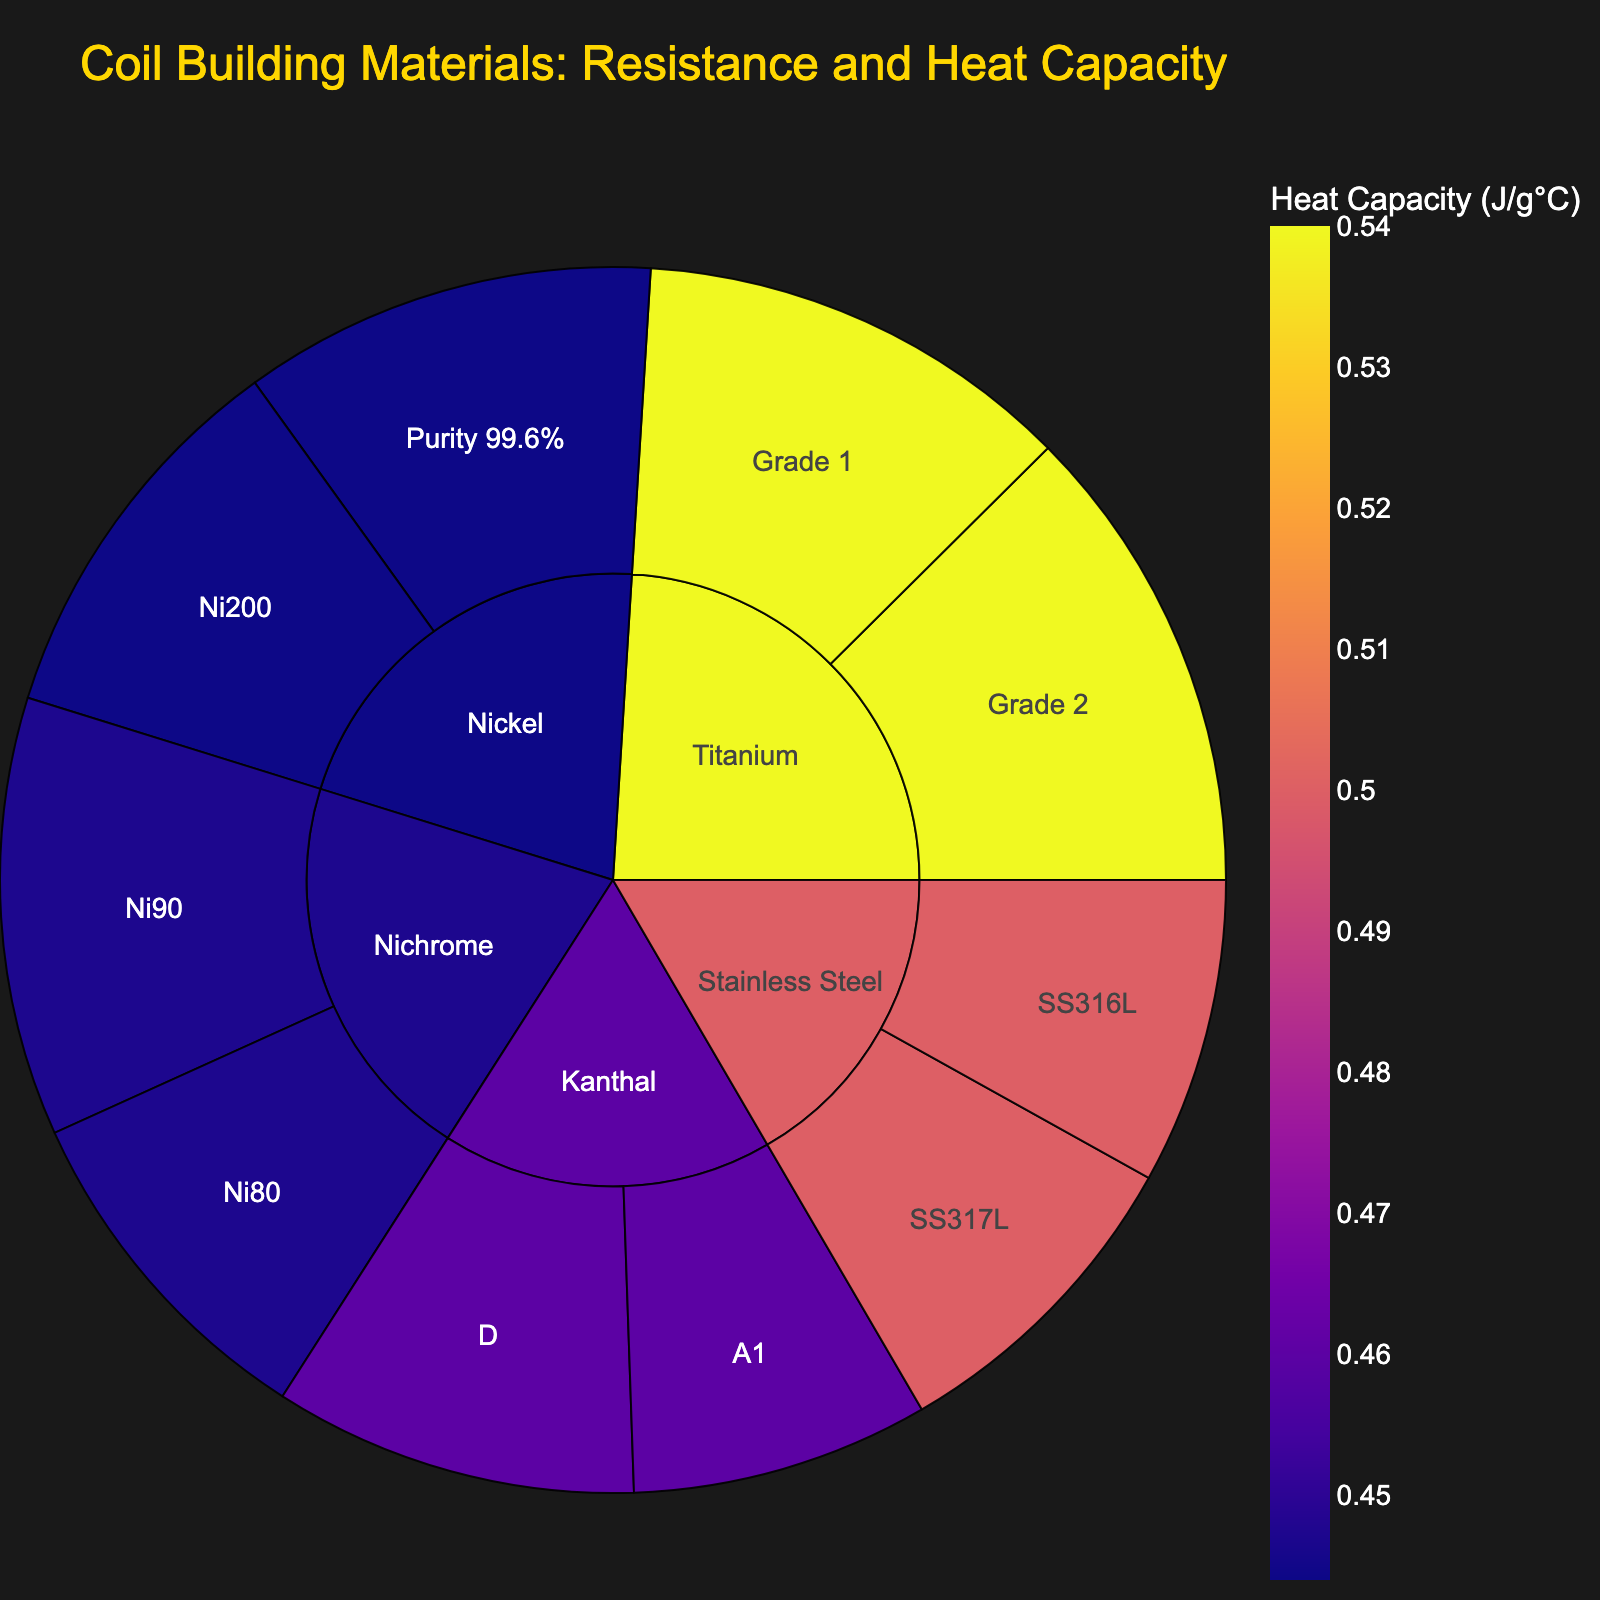What is the material with the highest resistance in the plot? By looking at the outermost section of the sunburst plot, one can identify the segment with the highest resistance value. Titanium Grade 2 has the highest resistance of 45.6 Ω/ft.
Answer: Titanium Grade 2 Which material has the highest heat capacity? To find the highest heat capacity, examine the color scale representing heat capacity within the sunburst plot. Titanium (both Grade 1 and Grade 2) has the highest heat capacity at 0.54 J/g°C.
Answer: Titanium How do the resistance values of Kanthal A1 and Nichrome Ni80 compare? Locate Kanthal A1 and Nichrome Ni80 on the plot. Kanthal A1 has a resistance of 28.8 Ω/ft, and Nichrome Ni80 has a resistance of 33.6 Ω/ft. Thus, Nichrome Ni80 has a higher resistance.
Answer: Nichrome Ni80 has higher resistance What is the difference in resistance between Stainless Steel SS316L and SS317L? Find the resistance values for both types of Stainless Steel: SS316L has 29.6 Ω/ft, and SS317L has 31.2 Ω/ft. The difference is 31.2 - 29.6 = 1.6 Ω/ft.
Answer: 1.6 Ω/ft Which material type has both high resistance and high heat capacity? Identify segments in the plot that have both high resistance and a high value in the color scale for heat capacity. Titanium Grade 2 stands out with a resistance of 45.6 Ω/ft and a heat capacity of 0.54 J/g°C.
Answer: Titanium Grade 2 Which two materials have the closest resistance values? Look for materials with closely positioned resistance values in the plot. Kanthal A1 (28.8 Ω/ft) and Stainless Steel SS316L (29.6 Ω/ft) have closely matched resistance values.
Answer: Kanthal A1 and Stainless Steel SS316L What's the combined resistance of all Nickel types in the plot? Sum the resistance values of all Nickel types i.e., Ni200 (37.6 Ω/ft) and Purity 99.6% (40 Ω/ft). The combined resistance is 37.6 + 40 = 77.6 Ω/ft.
Answer: 77.6 Ω/ft Comparing Kanthal and Nichrome, which material's types have a higher average heat capacity? Calculate the average heat capacity for both materials' types: For Kanthal (0.46, 0.46), the average is (0.46 + 0.46)/2 = 0.46 J/g°C. For Nichrome (0.447, 0.447), the average is (0.447 + 0.447)/2 = 0.447 J/g°C. Thus, Kanthal has a higher average heat capacity.
Answer: Kanthal What are the materials represented in the sunburst plot? The materials can be listed by viewing the inner segments of the sunburst plot. They include Kanthal, Nichrome, Stainless Steel, Titanium, and Nickel.
Answer: Kanthal, Nichrome, Stainless Steel, Titanium, Nickel 